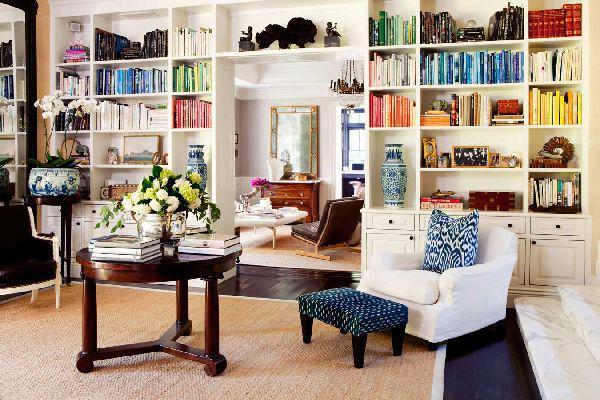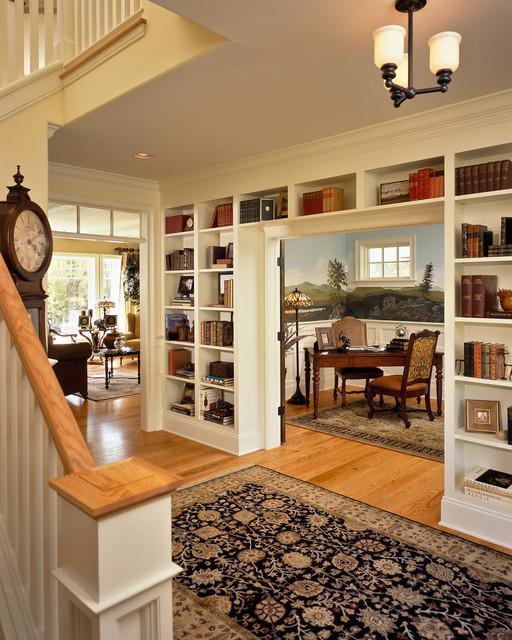The first image is the image on the left, the second image is the image on the right. Examine the images to the left and right. Is the description "The center table in one of the images holds a container with blooming flowers." accurate? Answer yes or no. Yes. The first image is the image on the left, the second image is the image on the right. Analyze the images presented: Is the assertion "A round coffee table is by a chair with a footstool in front of a wall-filling bookcase." valid? Answer yes or no. Yes. 